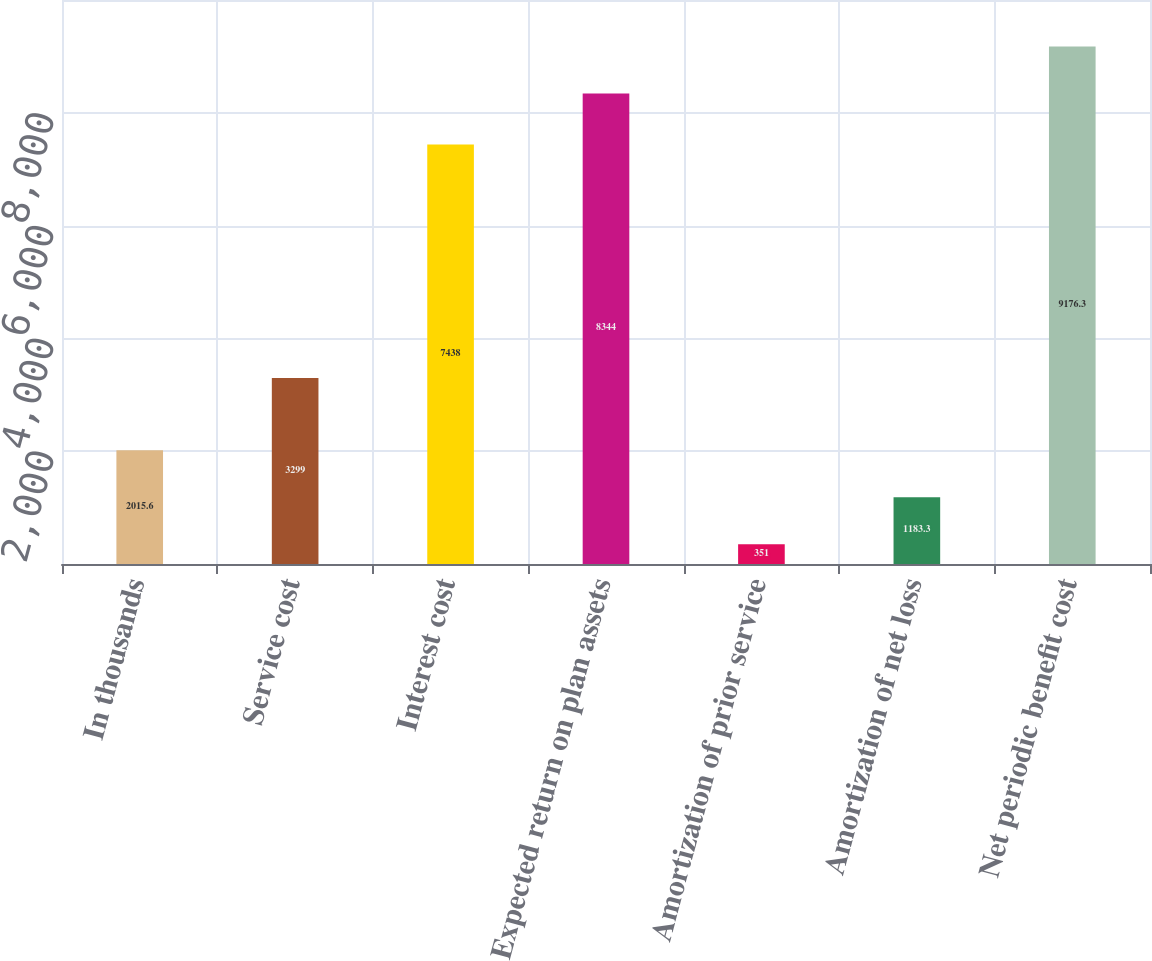Convert chart to OTSL. <chart><loc_0><loc_0><loc_500><loc_500><bar_chart><fcel>In thousands<fcel>Service cost<fcel>Interest cost<fcel>Expected return on plan assets<fcel>Amortization of prior service<fcel>Amortization of net loss<fcel>Net periodic benefit cost<nl><fcel>2015.6<fcel>3299<fcel>7438<fcel>8344<fcel>351<fcel>1183.3<fcel>9176.3<nl></chart> 